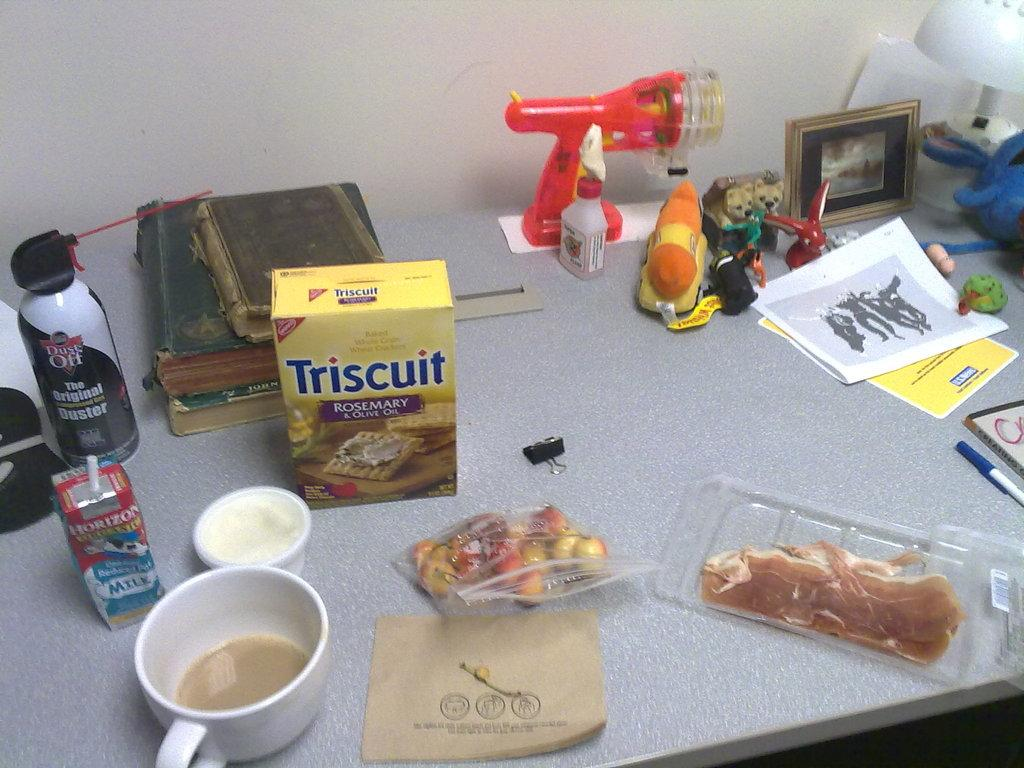What is the color of the surface in the image? The surface in the image is white. What is placed on the white surface? There is a cup, 2 boxes, few papers, 2 books, a photo frame, and a few other things on the surface. How many books are on the surface? There are 2 books on the surface. What type of object is used for displaying a photo in the image? There is a photo frame on the surface. What type of stone is used to answer questions in the image? There is no stone present in the image, and stones cannot be used to answer questions. 